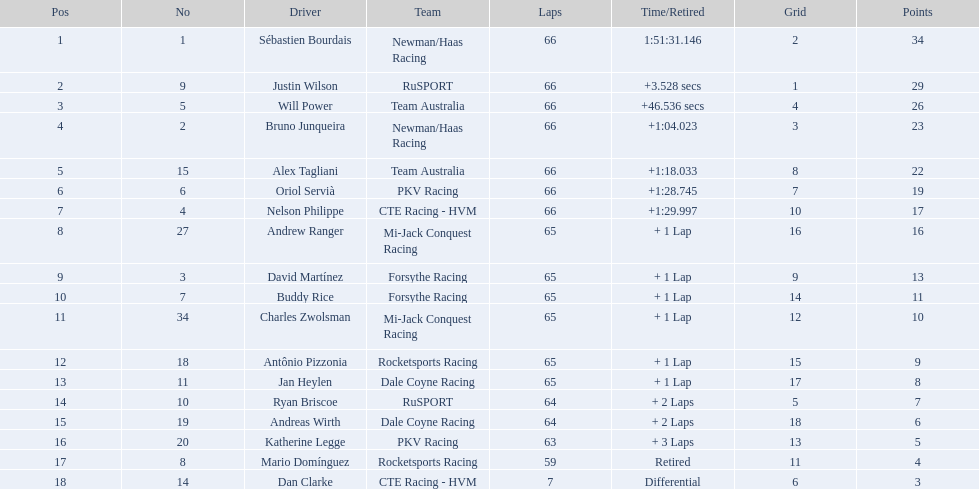Which drivers managed to obtain a minimum of 10 points? Sébastien Bourdais, Justin Wilson, Will Power, Bruno Junqueira, Alex Tagliani, Oriol Servià, Nelson Philippe, Andrew Ranger, David Martínez, Buddy Rice, Charles Zwolsman. Among them, who achieved 20 or more points? Sébastien Bourdais, Justin Wilson, Will Power, Bruno Junqueira, Alex Tagliani. Out of those 5, who had the highest score? Sébastien Bourdais. What numbers do the drivers have? 1, 9, 5, 2, 15, 6, 4, 27, 3, 7, 34, 18, 11, 10, 19, 20, 8, 14. Could you parse the entire table as a dict? {'header': ['Pos', 'No', 'Driver', 'Team', 'Laps', 'Time/Retired', 'Grid', 'Points'], 'rows': [['1', '1', 'Sébastien Bourdais', 'Newman/Haas Racing', '66', '1:51:31.146', '2', '34'], ['2', '9', 'Justin Wilson', 'RuSPORT', '66', '+3.528 secs', '1', '29'], ['3', '5', 'Will Power', 'Team Australia', '66', '+46.536 secs', '4', '26'], ['4', '2', 'Bruno Junqueira', 'Newman/Haas Racing', '66', '+1:04.023', '3', '23'], ['5', '15', 'Alex Tagliani', 'Team Australia', '66', '+1:18.033', '8', '22'], ['6', '6', 'Oriol Servià', 'PKV Racing', '66', '+1:28.745', '7', '19'], ['7', '4', 'Nelson Philippe', 'CTE Racing - HVM', '66', '+1:29.997', '10', '17'], ['8', '27', 'Andrew Ranger', 'Mi-Jack Conquest Racing', '65', '+ 1 Lap', '16', '16'], ['9', '3', 'David Martínez', 'Forsythe Racing', '65', '+ 1 Lap', '9', '13'], ['10', '7', 'Buddy Rice', 'Forsythe Racing', '65', '+ 1 Lap', '14', '11'], ['11', '34', 'Charles Zwolsman', 'Mi-Jack Conquest Racing', '65', '+ 1 Lap', '12', '10'], ['12', '18', 'Antônio Pizzonia', 'Rocketsports Racing', '65', '+ 1 Lap', '15', '9'], ['13', '11', 'Jan Heylen', 'Dale Coyne Racing', '65', '+ 1 Lap', '17', '8'], ['14', '10', 'Ryan Briscoe', 'RuSPORT', '64', '+ 2 Laps', '5', '7'], ['15', '19', 'Andreas Wirth', 'Dale Coyne Racing', '64', '+ 2 Laps', '18', '6'], ['16', '20', 'Katherine Legge', 'PKV Racing', '63', '+ 3 Laps', '13', '5'], ['17', '8', 'Mario Domínguez', 'Rocketsports Racing', '59', 'Retired', '11', '4'], ['18', '14', 'Dan Clarke', 'CTE Racing - HVM', '7', 'Differential', '6', '3']]} Is there a driver whose number is the same as their position? Sébastien Bourdais, Oriol Servià. If so, who has the highest ranking among them? Sébastien Bourdais. 